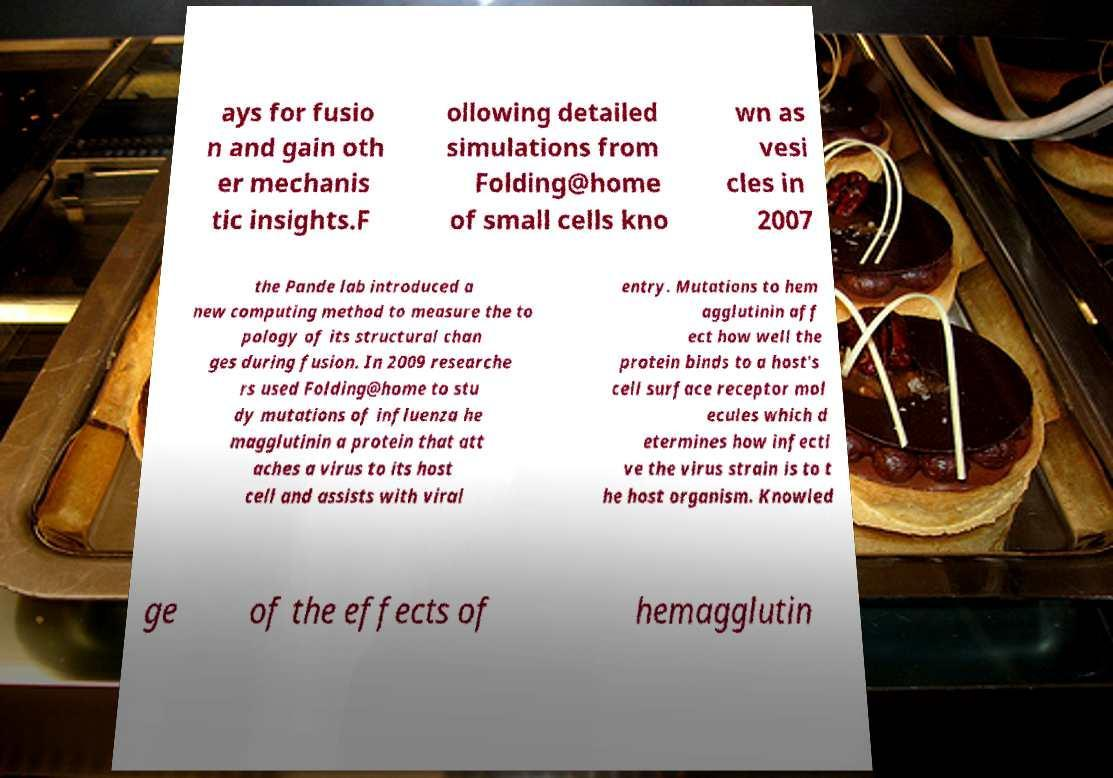Could you assist in decoding the text presented in this image and type it out clearly? ays for fusio n and gain oth er mechanis tic insights.F ollowing detailed simulations from Folding@home of small cells kno wn as vesi cles in 2007 the Pande lab introduced a new computing method to measure the to pology of its structural chan ges during fusion. In 2009 researche rs used Folding@home to stu dy mutations of influenza he magglutinin a protein that att aches a virus to its host cell and assists with viral entry. Mutations to hem agglutinin aff ect how well the protein binds to a host's cell surface receptor mol ecules which d etermines how infecti ve the virus strain is to t he host organism. Knowled ge of the effects of hemagglutin 